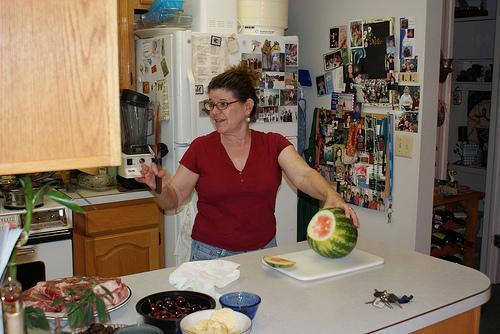How many people are there in this picture?
Give a very brief answer. 1. 